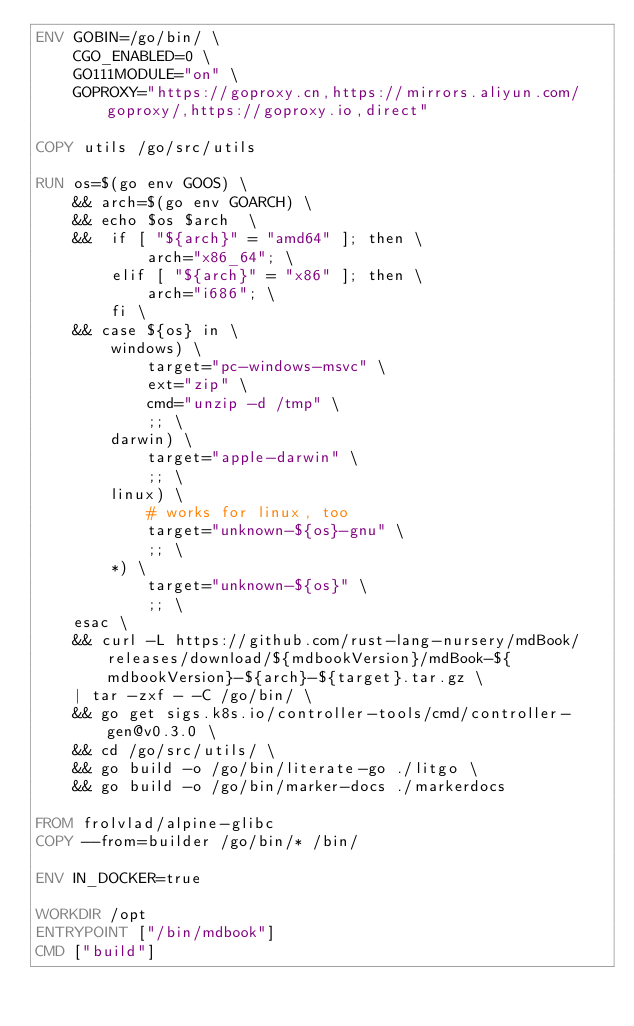<code> <loc_0><loc_0><loc_500><loc_500><_Dockerfile_>ENV GOBIN=/go/bin/ \
    CGO_ENABLED=0 \
    GO111MODULE="on" \
    GOPROXY="https://goproxy.cn,https://mirrors.aliyun.com/goproxy/,https://goproxy.io,direct"

COPY utils /go/src/utils

RUN os=$(go env GOOS) \
    && arch=$(go env GOARCH) \
    && echo $os $arch  \
    &&  if [ "${arch}" = "amd64" ]; then \
            arch="x86_64"; \
        elif [ "${arch}" = "x86" ]; then \
            arch="i686"; \
        fi \
    && case ${os} in \
        windows) \
            target="pc-windows-msvc" \
            ext="zip" \
            cmd="unzip -d /tmp" \
            ;; \
        darwin) \
            target="apple-darwin" \
            ;; \
        linux) \
            # works for linux, too
            target="unknown-${os}-gnu" \
            ;; \
        *) \
            target="unknown-${os}" \
            ;; \
    esac \
    && curl -L https://github.com/rust-lang-nursery/mdBook/releases/download/${mdbookVersion}/mdBook-${mdbookVersion}-${arch}-${target}.tar.gz \
    | tar -zxf - -C /go/bin/ \
    && go get sigs.k8s.io/controller-tools/cmd/controller-gen@v0.3.0 \
    && cd /go/src/utils/ \
    && go build -o /go/bin/literate-go ./litgo \
    && go build -o /go/bin/marker-docs ./markerdocs

FROM frolvlad/alpine-glibc
COPY --from=builder /go/bin/* /bin/

ENV IN_DOCKER=true

WORKDIR /opt
ENTRYPOINT ["/bin/mdbook"]
CMD ["build"]
</code> 